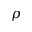Convert formula to latex. <formula><loc_0><loc_0><loc_500><loc_500>\rho</formula> 